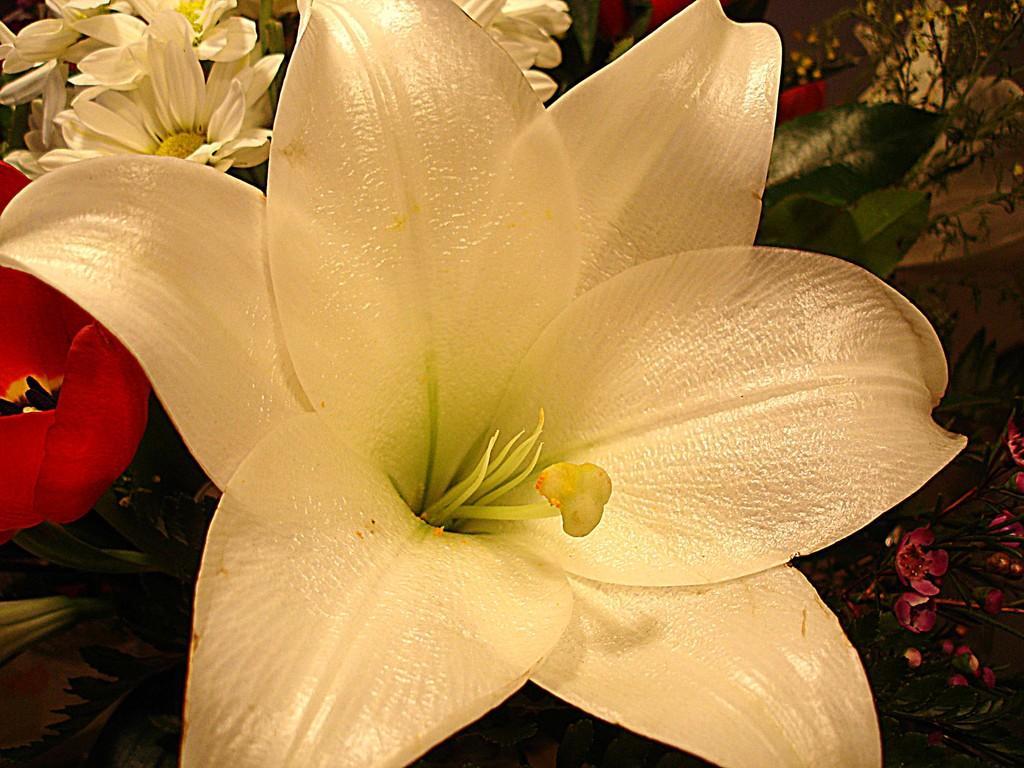In one or two sentences, can you explain what this image depicts? In the image we can see a flower. Behind the flower there are some flowers and plants. 